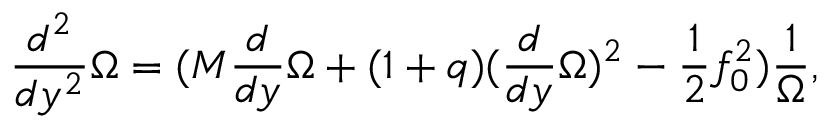Convert formula to latex. <formula><loc_0><loc_0><loc_500><loc_500>\frac { d ^ { 2 } } { d y ^ { 2 } } \Omega = ( M \frac { d } { d y } \Omega + ( 1 + q ) ( \frac { d } { d y } \Omega ) ^ { 2 } - \frac { 1 } { 2 } f _ { 0 } ^ { 2 } ) \frac { 1 } { \Omega } ,</formula> 